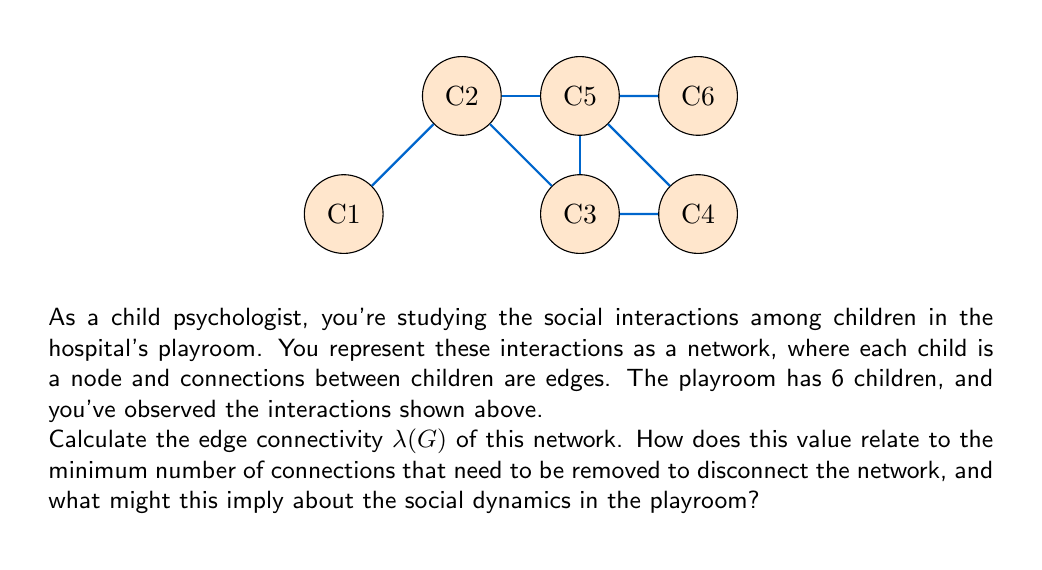Solve this math problem. To solve this problem, we need to understand the concept of edge connectivity and how to calculate it for the given network. Let's break it down step-by-step:

1) Edge connectivity $\lambda(G)$ is defined as the minimum number of edges that need to be removed to disconnect the graph.

2) To find $\lambda(G)$, we need to identify the minimum cut set of the graph.

3) Looking at the graph:
   - There are 6 nodes (children) labeled C1 to C6.
   - There are 7 edges (interactions) connecting these nodes.

4) We can see that removing any single edge will not disconnect the graph.

5) However, if we remove the edges C1-C2 and C2-C3, the graph becomes disconnected:
   - This separates C1 from the rest of the network.

6) We can verify that there's no way to disconnect the graph by removing only one edge.

7) Therefore, the edge connectivity $\lambda(G) = 2$.

8) This means that at least 2 connections need to be removed to isolate any child from the group.

9) In terms of social dynamics, this implies:
   - The group is relatively well-connected, as no single interaction breaking can isolate a child.
   - However, there are some children (like C1) who are more vulnerable to isolation if multiple interactions break down.
   - The structure suggests a mix of strong and weak ties in the social network.
Answer: $\lambda(G) = 2$ 